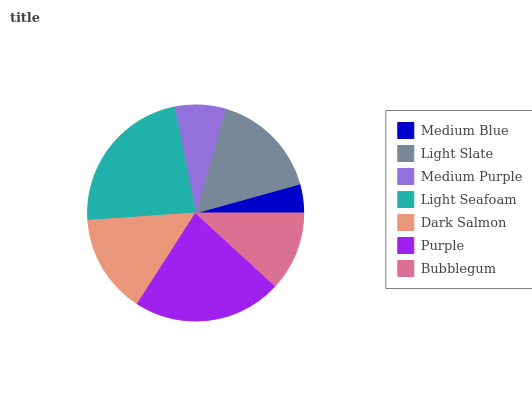Is Medium Blue the minimum?
Answer yes or no. Yes. Is Light Seafoam the maximum?
Answer yes or no. Yes. Is Light Slate the minimum?
Answer yes or no. No. Is Light Slate the maximum?
Answer yes or no. No. Is Light Slate greater than Medium Blue?
Answer yes or no. Yes. Is Medium Blue less than Light Slate?
Answer yes or no. Yes. Is Medium Blue greater than Light Slate?
Answer yes or no. No. Is Light Slate less than Medium Blue?
Answer yes or no. No. Is Dark Salmon the high median?
Answer yes or no. Yes. Is Dark Salmon the low median?
Answer yes or no. Yes. Is Bubblegum the high median?
Answer yes or no. No. Is Medium Blue the low median?
Answer yes or no. No. 